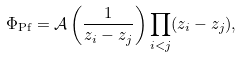<formula> <loc_0><loc_0><loc_500><loc_500>\Phi _ { \text {Pf} } = \mathcal { A } \left ( \frac { 1 } { z _ { i } - z _ { j } } \right ) \prod _ { i < j } ( z _ { i } - z _ { j } ) ,</formula> 